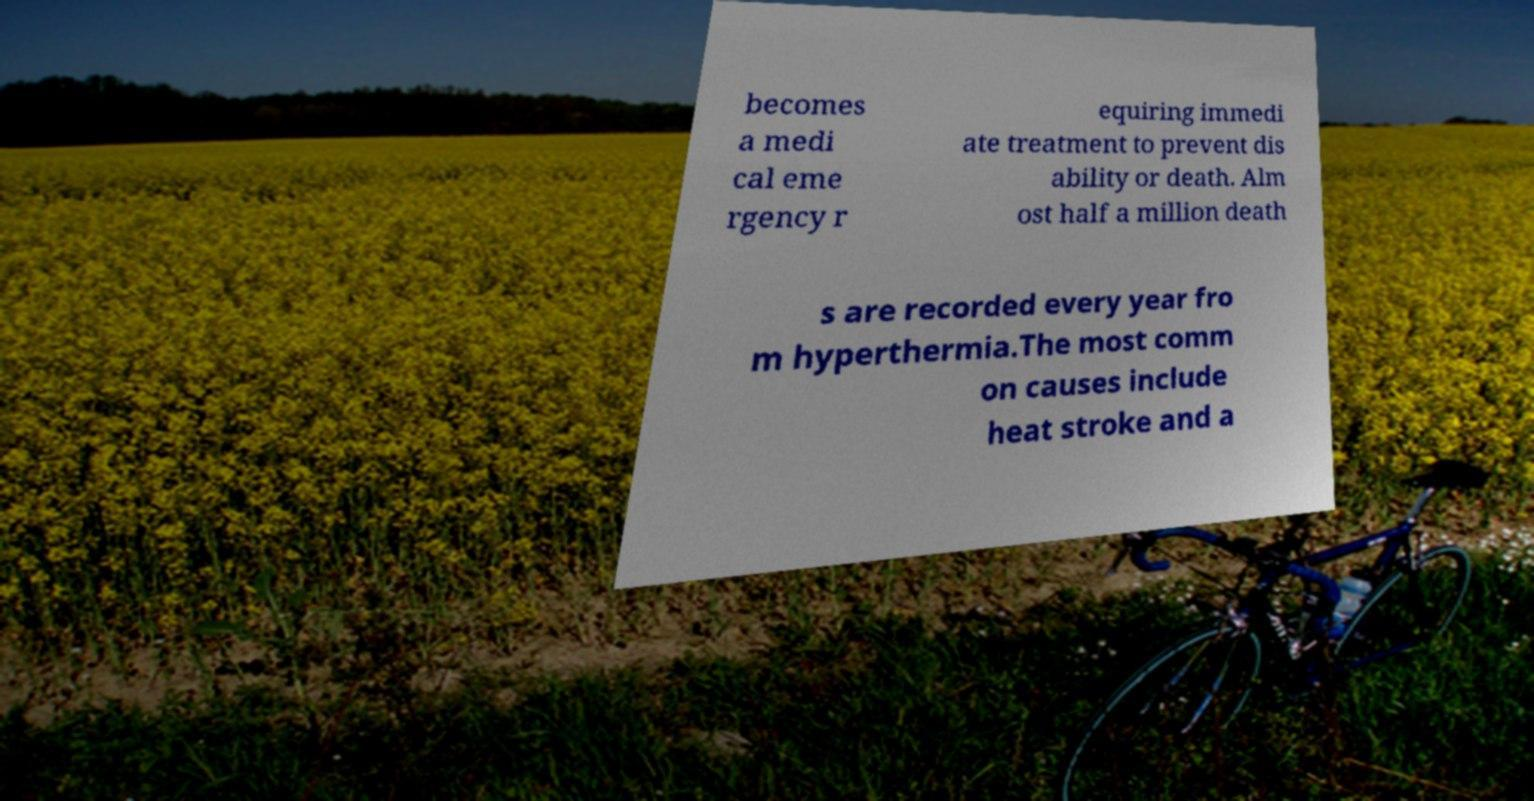Can you accurately transcribe the text from the provided image for me? becomes a medi cal eme rgency r equiring immedi ate treatment to prevent dis ability or death. Alm ost half a million death s are recorded every year fro m hyperthermia.The most comm on causes include heat stroke and a 